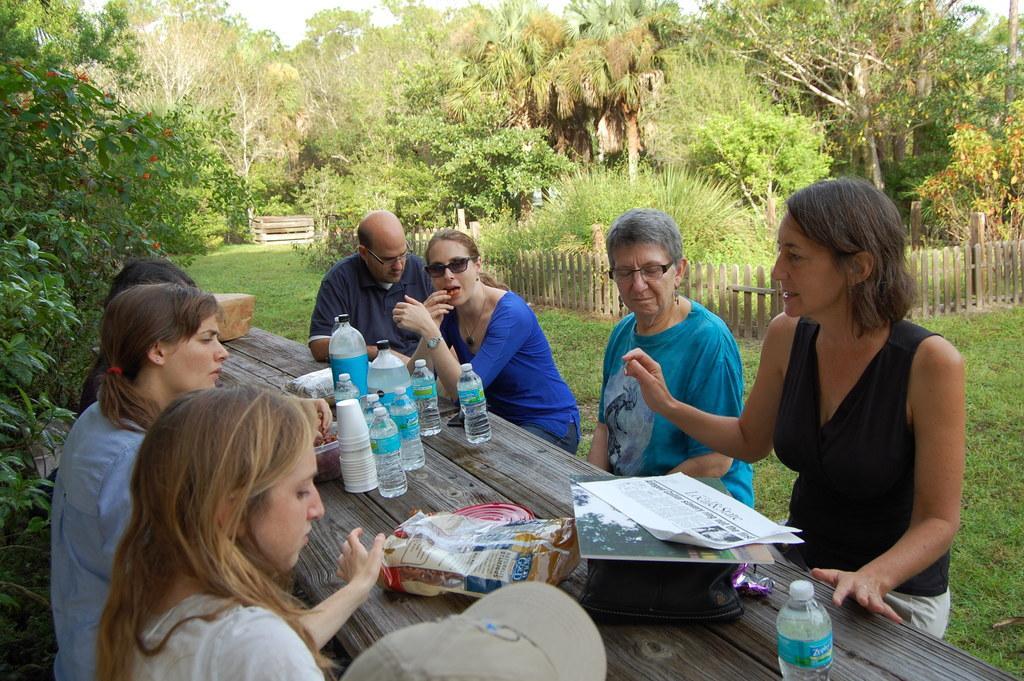Can you describe this image briefly? In this image I can see there are persons sitting on the grass. And there is a table on the table there are bottles, Cover, Box, Paper, Book and a stone. And there is a fence, Trees and flowers. And at the top there is a sky. 